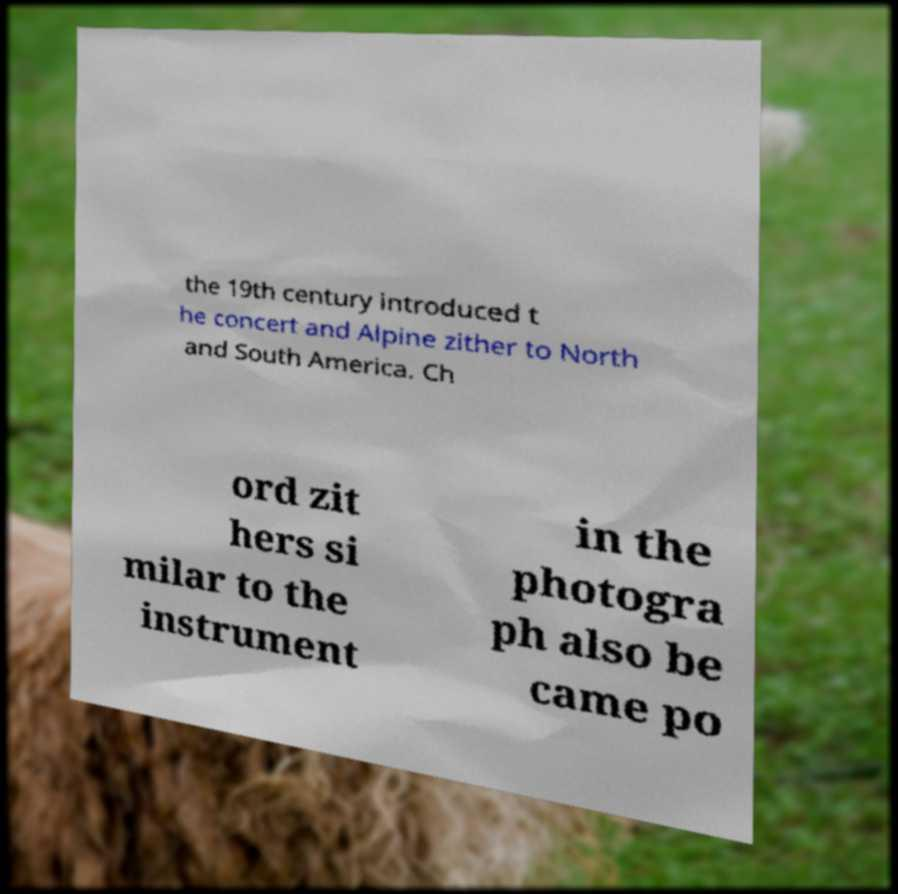Please identify and transcribe the text found in this image. the 19th century introduced t he concert and Alpine zither to North and South America. Ch ord zit hers si milar to the instrument in the photogra ph also be came po 